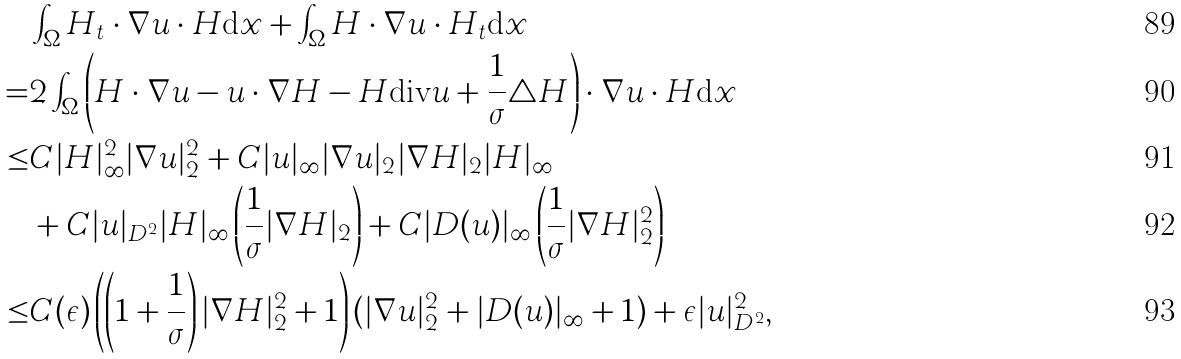<formula> <loc_0><loc_0><loc_500><loc_500>& \int _ { \Omega } H _ { t } \cdot \nabla u \cdot H \text {d} x + \int _ { \Omega } H \cdot \nabla u \cdot H _ { t } \text {d} x \\ = & 2 \int _ { \Omega } \left ( H \cdot \nabla u - u \cdot \nabla H - H \text {div} u + \frac { 1 } { \sigma } \triangle H \right ) \cdot \nabla u \cdot H \text {d} x \\ \leq & C | H | ^ { 2 } _ { \infty } | \nabla u | ^ { 2 } _ { 2 } + C | u | _ { \infty } | \nabla u | _ { 2 } | \nabla H | _ { 2 } | H | _ { \infty } \\ & + C | u | _ { D ^ { 2 } } | H | _ { \infty } \left ( \frac { 1 } { \sigma } | \nabla H | _ { 2 } \right ) + C | D ( u ) | _ { \infty } \left ( \frac { 1 } { \sigma } | \nabla H | ^ { 2 } _ { 2 } \right ) \\ \leq & C ( \epsilon ) \left ( \left ( 1 + \frac { 1 } { \sigma } \right ) | \nabla H | ^ { 2 } _ { 2 } + 1 \right ) ( | \nabla u | ^ { 2 } _ { 2 } + | D ( u ) | _ { \infty } + 1 ) + \epsilon | u | ^ { 2 } _ { D ^ { 2 } } ,</formula> 